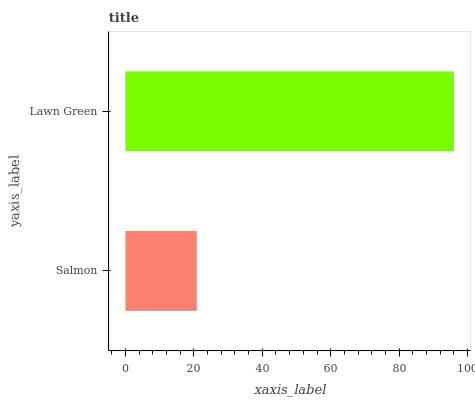Is Salmon the minimum?
Answer yes or no. Yes. Is Lawn Green the maximum?
Answer yes or no. Yes. Is Lawn Green the minimum?
Answer yes or no. No. Is Lawn Green greater than Salmon?
Answer yes or no. Yes. Is Salmon less than Lawn Green?
Answer yes or no. Yes. Is Salmon greater than Lawn Green?
Answer yes or no. No. Is Lawn Green less than Salmon?
Answer yes or no. No. Is Lawn Green the high median?
Answer yes or no. Yes. Is Salmon the low median?
Answer yes or no. Yes. Is Salmon the high median?
Answer yes or no. No. Is Lawn Green the low median?
Answer yes or no. No. 